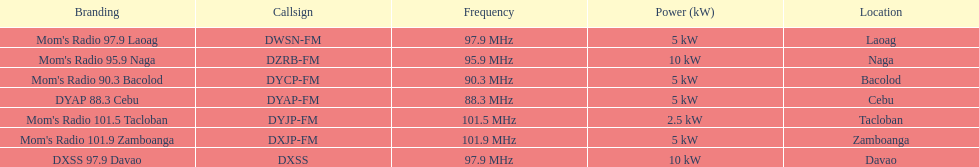What are all of the frequencies? 97.9 MHz, 95.9 MHz, 90.3 MHz, 88.3 MHz, 101.5 MHz, 101.9 MHz, 97.9 MHz. Which of these frequencies is the lowest? 88.3 MHz. Which branding does this frequency belong to? DYAP 88.3 Cebu. 